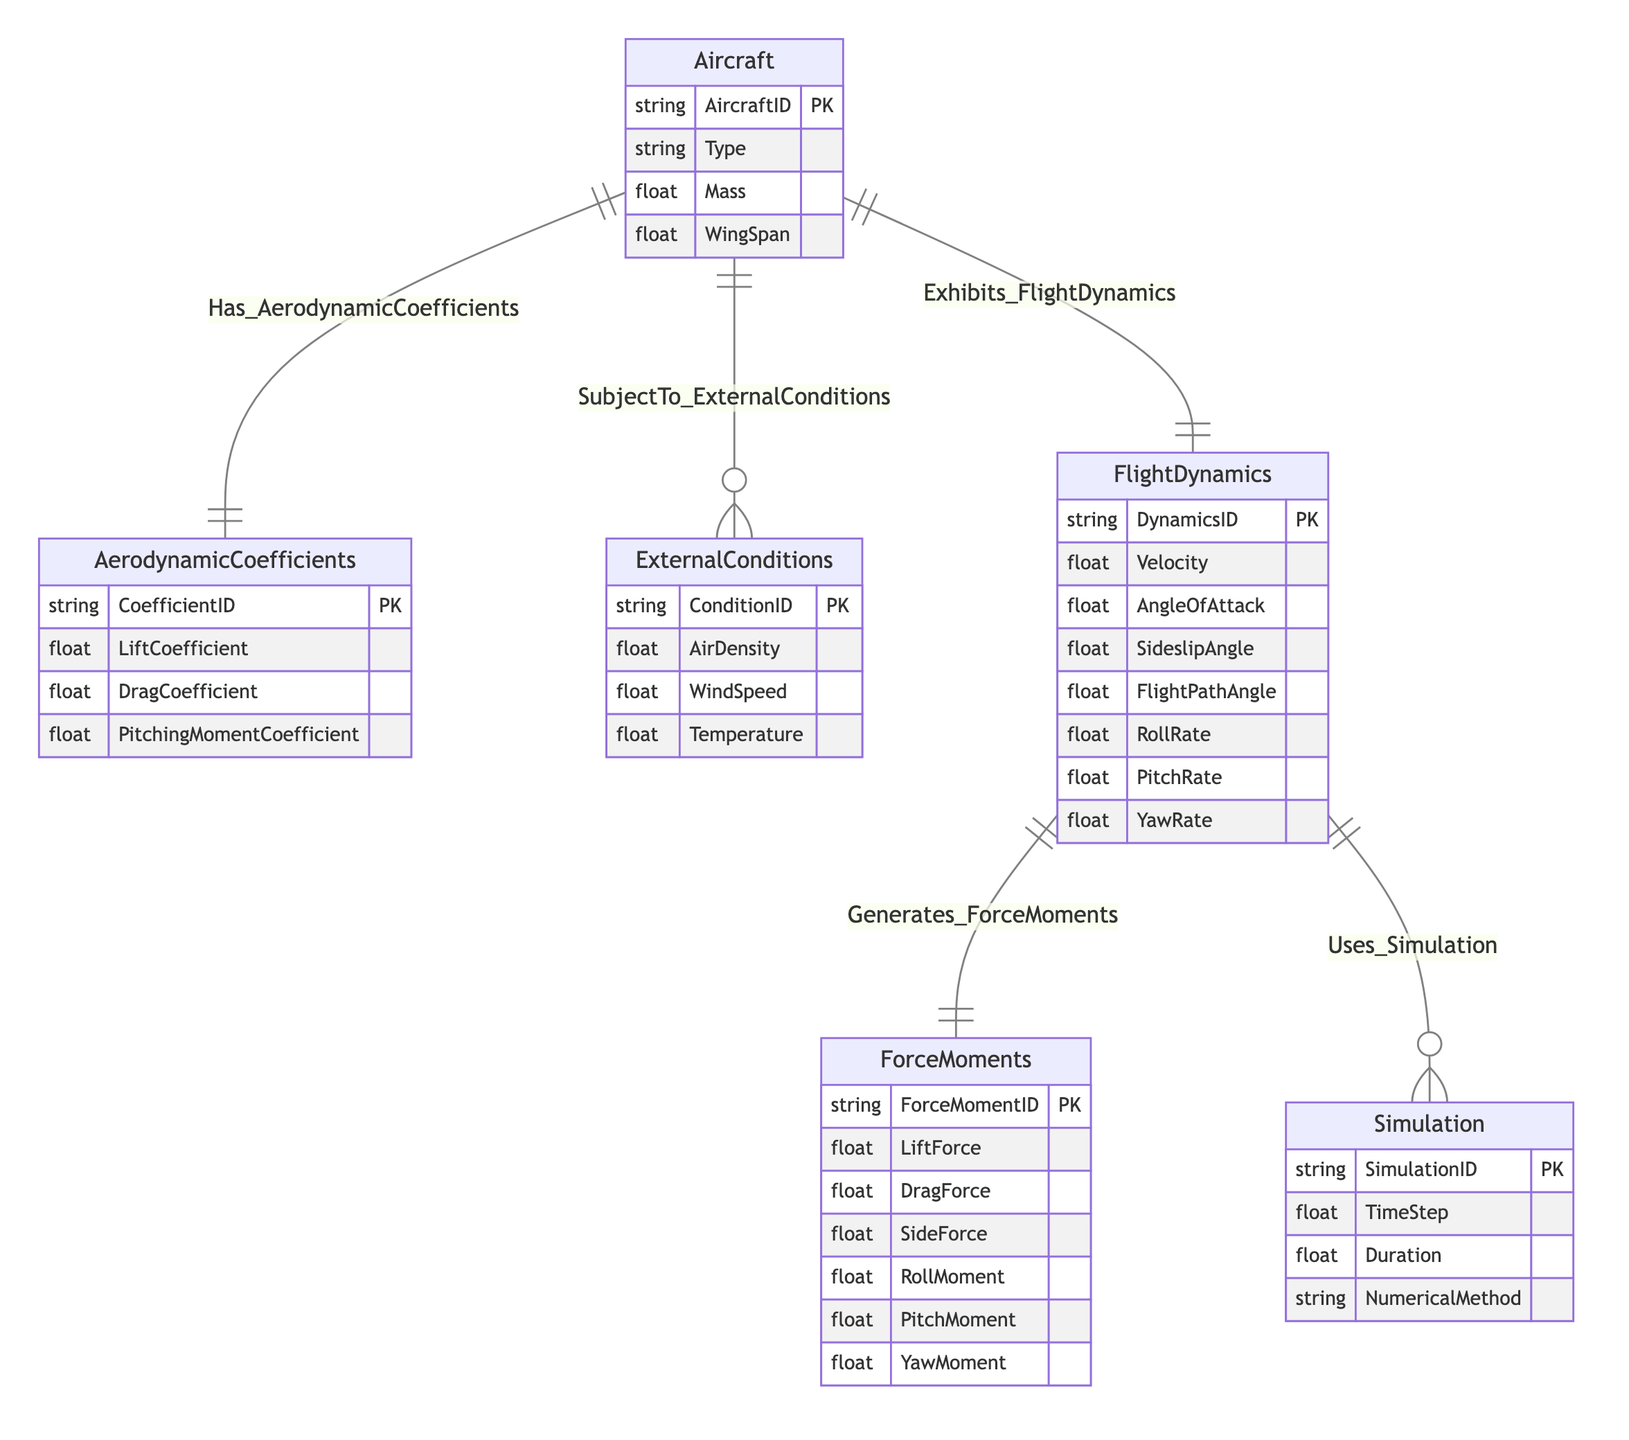What are the attributes of the Aircraft entity? The Aircraft entity has the following attributes: AircraftID, Type, Mass, and WingSpan, which can be identified directly from the entity's box in the diagram.
Answer: AircraftID, Type, Mass, WingSpan How many relationships does the Aircraft entity have? The Aircraft entity has three relationships: it is linked to AerodynamicCoefficients, ExternalConditions, and FlightDynamics. Counting these relationships from the diagram gives us a total of three.
Answer: 3 What is the cardinality of the relationship between FlightDynamics and ForceMoments? The cardinality of the relationship between FlightDynamics and ForceMoments is 1-to-1, as indicated by the relationship line and symbols connecting these two entities in the diagram.
Answer: 1-to-1 Which entity exhibits Flight Dynamics? The Aircraft entity exhibits Flight Dynamics, as shown by the direct relationship labeled "Exhibits_FlightDynamics" that connects Aircraft to FlightDynamics in the diagram.
Answer: Aircraft How many attributes does the Simulation entity have? The Simulation entity contains four attributes: SimulationID, TimeStep, Duration, and NumericalMethod, which can be seen from the details under the Simulation entity in the diagram.
Answer: 4 What entities are involved in the relationship "Uses_Simulation"? The relationship "Uses_Simulation" involves the FlightDynamics entity and the Simulation entity, as illustrated by the connecting line in the diagram.
Answer: FlightDynamics, Simulation Which entity has a 1-to-many relationship with Aircraft? The ExternalConditions entity has a 1-to-many relationship with Aircraft, as indicated by the relationship labeled "SubjectTo_ExternalConditions" showing the connection and cardinality in the diagram.
Answer: ExternalConditions What is the primary key of the AerodynamicCoefficients entity? The primary key of the AerodynamicCoefficients entity is CoefficientID, which is specified in the attributes list for that entity in the diagram.
Answer: CoefficientID What does the FlightDynamics entity generate? The FlightDynamics entity generates ForceMoments, as indicated by the relationship labeled "Generates_ForceMoments" that connects FlightDynamics to ForceMoments in the diagram.
Answer: ForceMoments 